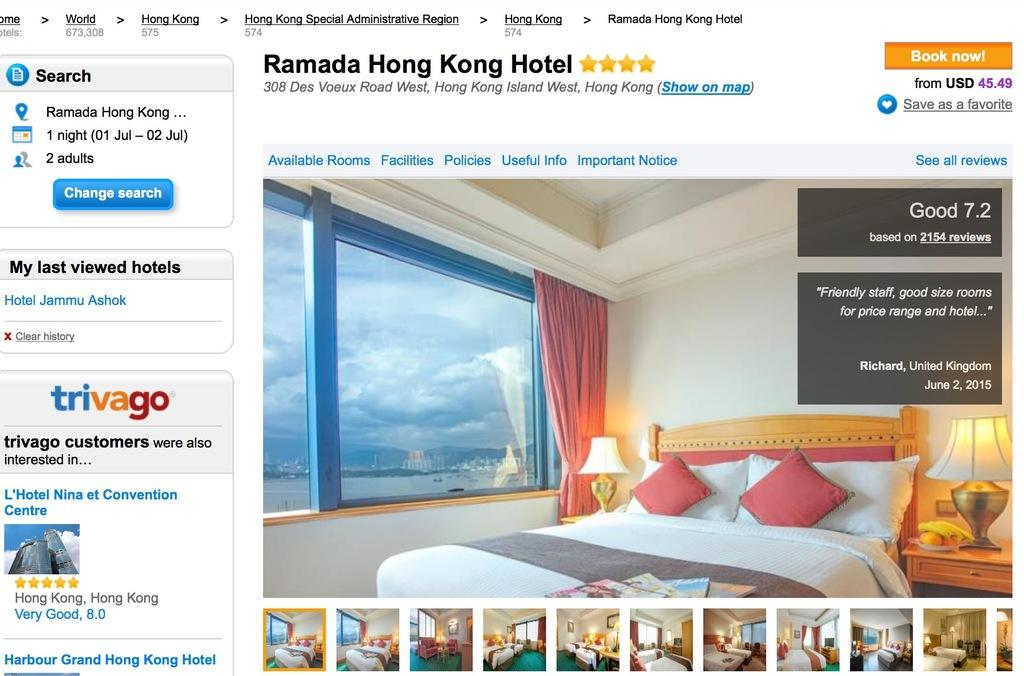What type of furniture is present in the room? There is a bed in the room. What can be used for illumination in the room? There are lamps in the room. What is used to cover the window in the room? There is a curtain in the room. What allows natural light to enter the room? There is a window in the room. What type of coil is visible in the room? There is no coil present in the room. Can you describe the pail used for water storage in the room? There is no pail for water storage in the room. 